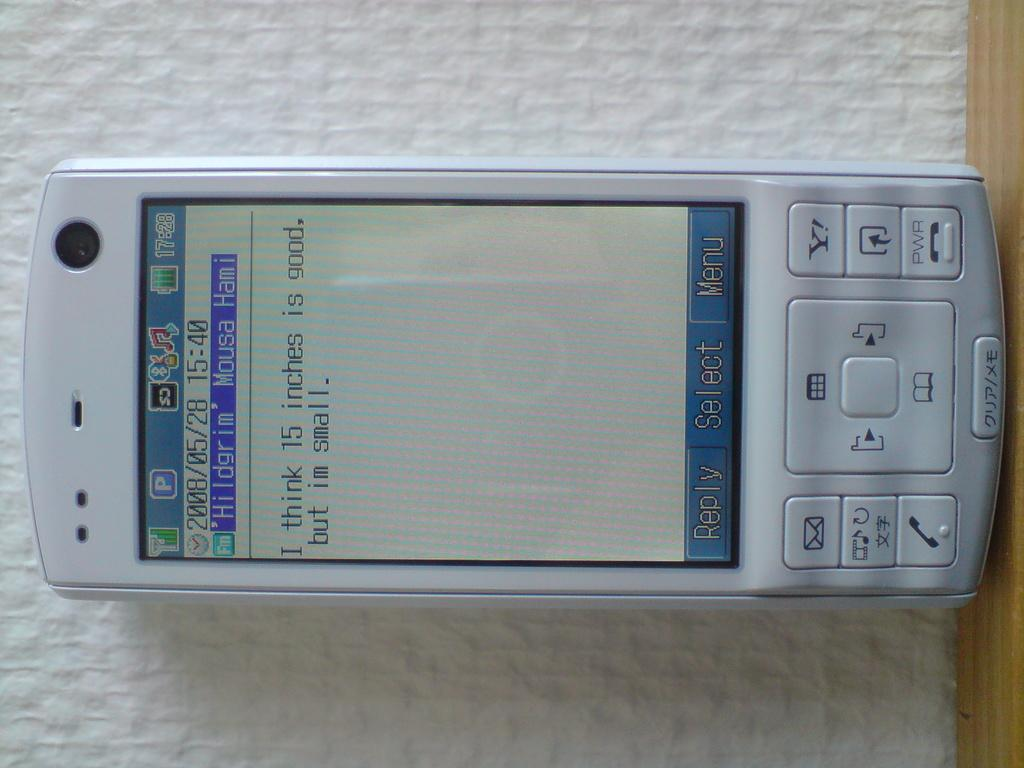Provide a one-sentence caption for the provided image. white cellphone displaying text message I think 15 inches is good, but im small. 